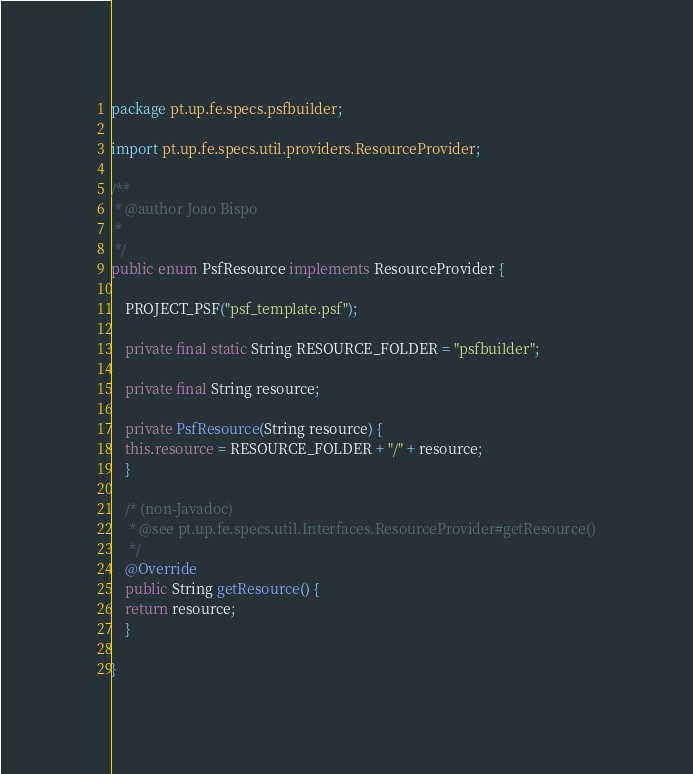<code> <loc_0><loc_0><loc_500><loc_500><_Java_>
package pt.up.fe.specs.psfbuilder;

import pt.up.fe.specs.util.providers.ResourceProvider;

/**
 * @author Joao Bispo
 * 
 */
public enum PsfResource implements ResourceProvider {

    PROJECT_PSF("psf_template.psf");

    private final static String RESOURCE_FOLDER = "psfbuilder";

    private final String resource;

    private PsfResource(String resource) {
	this.resource = RESOURCE_FOLDER + "/" + resource;
    }

    /* (non-Javadoc)
     * @see pt.up.fe.specs.util.Interfaces.ResourceProvider#getResource()
     */
    @Override
    public String getResource() {
	return resource;
    }

}
</code> 